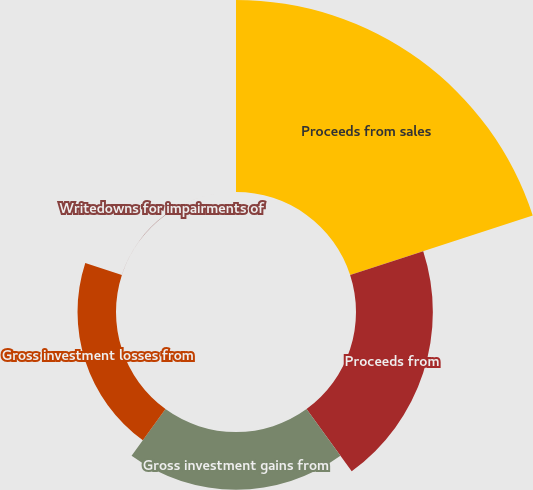Convert chart to OTSL. <chart><loc_0><loc_0><loc_500><loc_500><pie_chart><fcel>Proceeds from sales<fcel>Proceeds from<fcel>Gross investment gains from<fcel>Gross investment losses from<fcel>Writedowns for impairments of<nl><fcel>52.59%<fcel>21.05%<fcel>15.79%<fcel>10.54%<fcel>0.02%<nl></chart> 